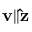Convert formula to latex. <formula><loc_0><loc_0><loc_500><loc_500>v \| \hat { z }</formula> 